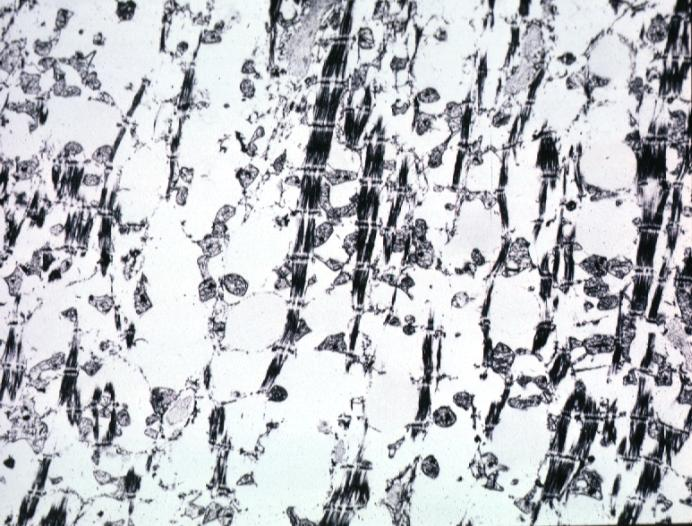what is present?
Answer the question using a single word or phrase. Chronic ischemia 